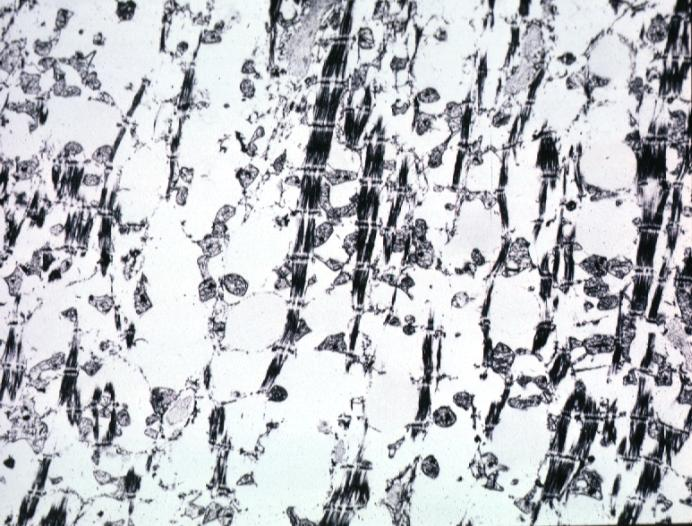what is present?
Answer the question using a single word or phrase. Chronic ischemia 